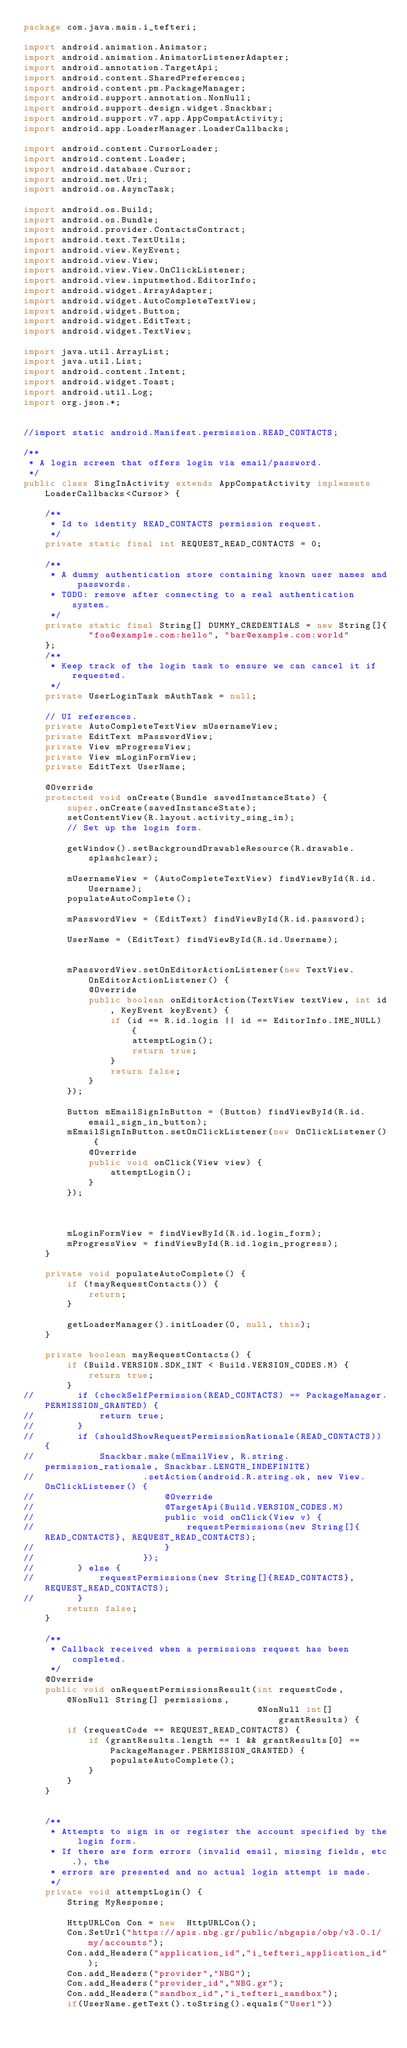<code> <loc_0><loc_0><loc_500><loc_500><_Java_>package com.java.main.i_tefteri;

import android.animation.Animator;
import android.animation.AnimatorListenerAdapter;
import android.annotation.TargetApi;
import android.content.SharedPreferences;
import android.content.pm.PackageManager;
import android.support.annotation.NonNull;
import android.support.design.widget.Snackbar;
import android.support.v7.app.AppCompatActivity;
import android.app.LoaderManager.LoaderCallbacks;

import android.content.CursorLoader;
import android.content.Loader;
import android.database.Cursor;
import android.net.Uri;
import android.os.AsyncTask;

import android.os.Build;
import android.os.Bundle;
import android.provider.ContactsContract;
import android.text.TextUtils;
import android.view.KeyEvent;
import android.view.View;
import android.view.View.OnClickListener;
import android.view.inputmethod.EditorInfo;
import android.widget.ArrayAdapter;
import android.widget.AutoCompleteTextView;
import android.widget.Button;
import android.widget.EditText;
import android.widget.TextView;

import java.util.ArrayList;
import java.util.List;
import android.content.Intent;
import android.widget.Toast;
import android.util.Log;
import org.json.*;


//import static android.Manifest.permission.READ_CONTACTS;

/**
 * A login screen that offers login via email/password.
 */
public class SingInActivity extends AppCompatActivity implements LoaderCallbacks<Cursor> {

    /**
     * Id to identity READ_CONTACTS permission request.
     */
    private static final int REQUEST_READ_CONTACTS = 0;

    /**
     * A dummy authentication store containing known user names and passwords.
     * TODO: remove after connecting to a real authentication system.
     */
    private static final String[] DUMMY_CREDENTIALS = new String[]{
            "foo@example.com:hello", "bar@example.com:world"
    };
    /**
     * Keep track of the login task to ensure we can cancel it if requested.
     */
    private UserLoginTask mAuthTask = null;

    // UI references.
    private AutoCompleteTextView mUsernameView;
    private EditText mPasswordView;
    private View mProgressView;
    private View mLoginFormView;
    private EditText UserName;

    @Override
    protected void onCreate(Bundle savedInstanceState) {
        super.onCreate(savedInstanceState);
        setContentView(R.layout.activity_sing_in);
        // Set up the login form.

        getWindow().setBackgroundDrawableResource(R.drawable.splashclear);

        mUsernameView = (AutoCompleteTextView) findViewById(R.id.Username);
        populateAutoComplete();

        mPasswordView = (EditText) findViewById(R.id.password);

        UserName = (EditText) findViewById(R.id.Username);


        mPasswordView.setOnEditorActionListener(new TextView.OnEditorActionListener() {
            @Override
            public boolean onEditorAction(TextView textView, int id, KeyEvent keyEvent) {
                if (id == R.id.login || id == EditorInfo.IME_NULL) {
                    attemptLogin();
                    return true;
                }
                return false;
            }
        });

        Button mEmailSignInButton = (Button) findViewById(R.id.email_sign_in_button);
        mEmailSignInButton.setOnClickListener(new OnClickListener() {
            @Override
            public void onClick(View view) {
                attemptLogin();
            }
        });



        mLoginFormView = findViewById(R.id.login_form);
        mProgressView = findViewById(R.id.login_progress);
    }

    private void populateAutoComplete() {
        if (!mayRequestContacts()) {
            return;
        }

        getLoaderManager().initLoader(0, null, this);
    }

    private boolean mayRequestContacts() {
        if (Build.VERSION.SDK_INT < Build.VERSION_CODES.M) {
            return true;
        }
//        if (checkSelfPermission(READ_CONTACTS) == PackageManager.PERMISSION_GRANTED) {
//            return true;
//        }
//        if (shouldShowRequestPermissionRationale(READ_CONTACTS)) {
//            Snackbar.make(mEmailView, R.string.permission_rationale, Snackbar.LENGTH_INDEFINITE)
//                    .setAction(android.R.string.ok, new View.OnClickListener() {
//                        @Override
//                        @TargetApi(Build.VERSION_CODES.M)
//                        public void onClick(View v) {
//                            requestPermissions(new String[]{READ_CONTACTS}, REQUEST_READ_CONTACTS);
//                        }
//                    });
//        } else {
//            requestPermissions(new String[]{READ_CONTACTS}, REQUEST_READ_CONTACTS);
//        }
        return false;
    }

    /**
     * Callback received when a permissions request has been completed.
     */
    @Override
    public void onRequestPermissionsResult(int requestCode, @NonNull String[] permissions,
                                           @NonNull int[] grantResults) {
        if (requestCode == REQUEST_READ_CONTACTS) {
            if (grantResults.length == 1 && grantResults[0] == PackageManager.PERMISSION_GRANTED) {
                populateAutoComplete();
            }
        }
    }


    /**
     * Attempts to sign in or register the account specified by the login form.
     * If there are form errors (invalid email, missing fields, etc.), the
     * errors are presented and no actual login attempt is made.
     */
    private void attemptLogin() {
        String MyResponse;

        HttpURLCon Con = new  HttpURLCon();
        Con.SetUrl("https://apis.nbg.gr/public/nbgapis/obp/v3.0.1/my/accounts");
        Con.add_Headers("application_id","i_tefteri_application_id");
        Con.add_Headers("provider","NBG");
        Con.add_Headers("provider_id","NBG.gr");
        Con.add_Headers("sandbox_id","i_tefteri_sandbox");
        if(UserName.getText().toString().equals("User1"))</code> 